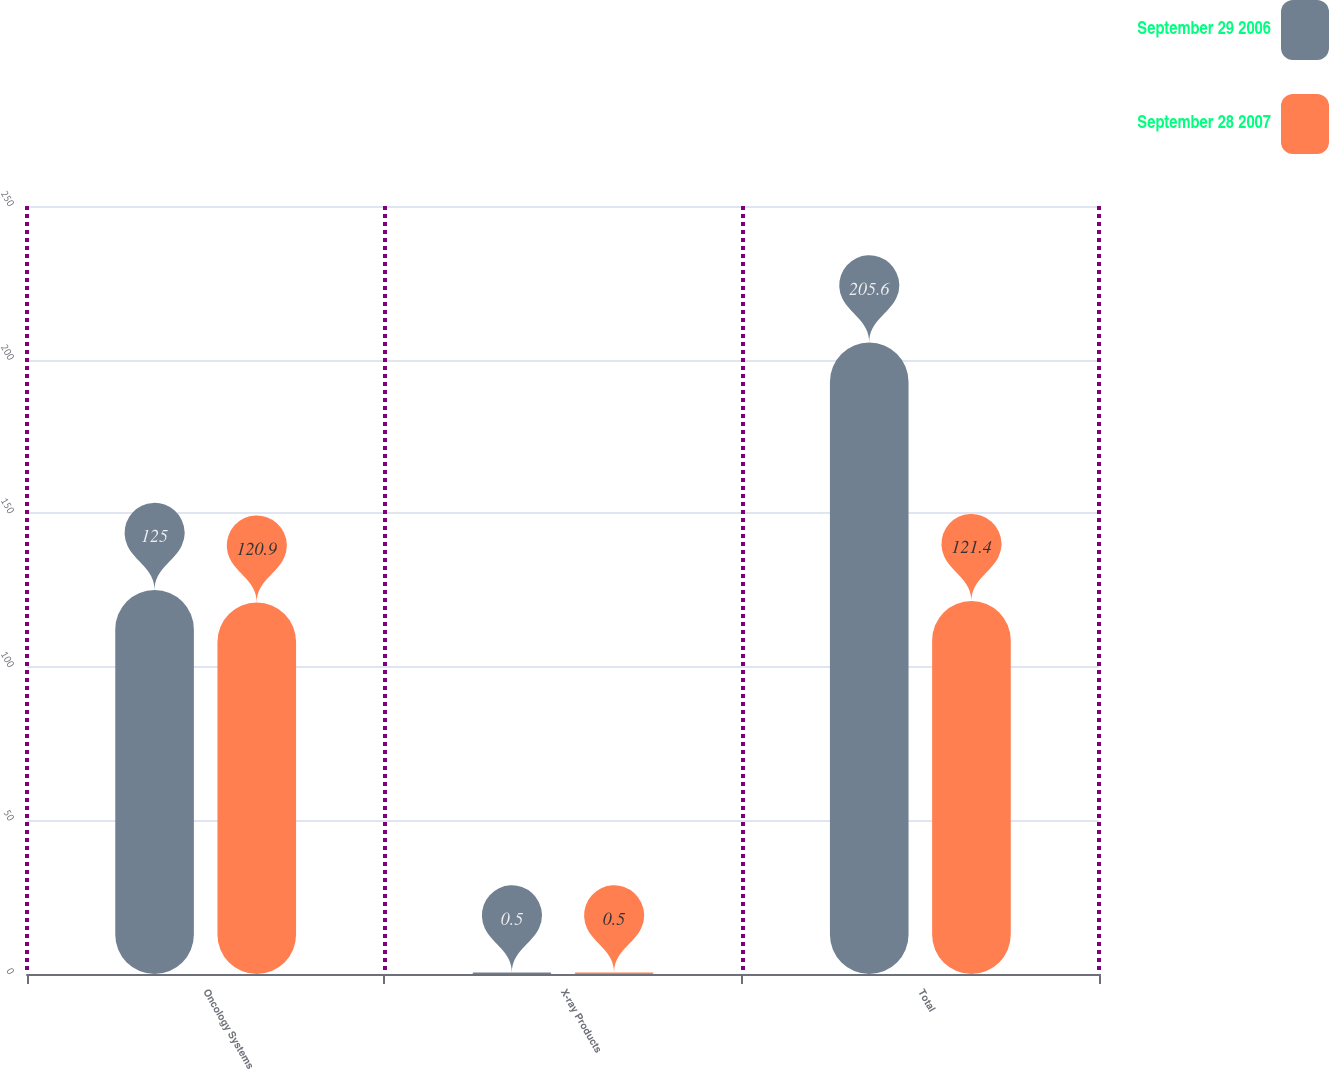Convert chart. <chart><loc_0><loc_0><loc_500><loc_500><stacked_bar_chart><ecel><fcel>Oncology Systems<fcel>X-ray Products<fcel>Total<nl><fcel>September 29 2006<fcel>125<fcel>0.5<fcel>205.6<nl><fcel>September 28 2007<fcel>120.9<fcel>0.5<fcel>121.4<nl></chart> 